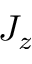Convert formula to latex. <formula><loc_0><loc_0><loc_500><loc_500>J _ { z }</formula> 